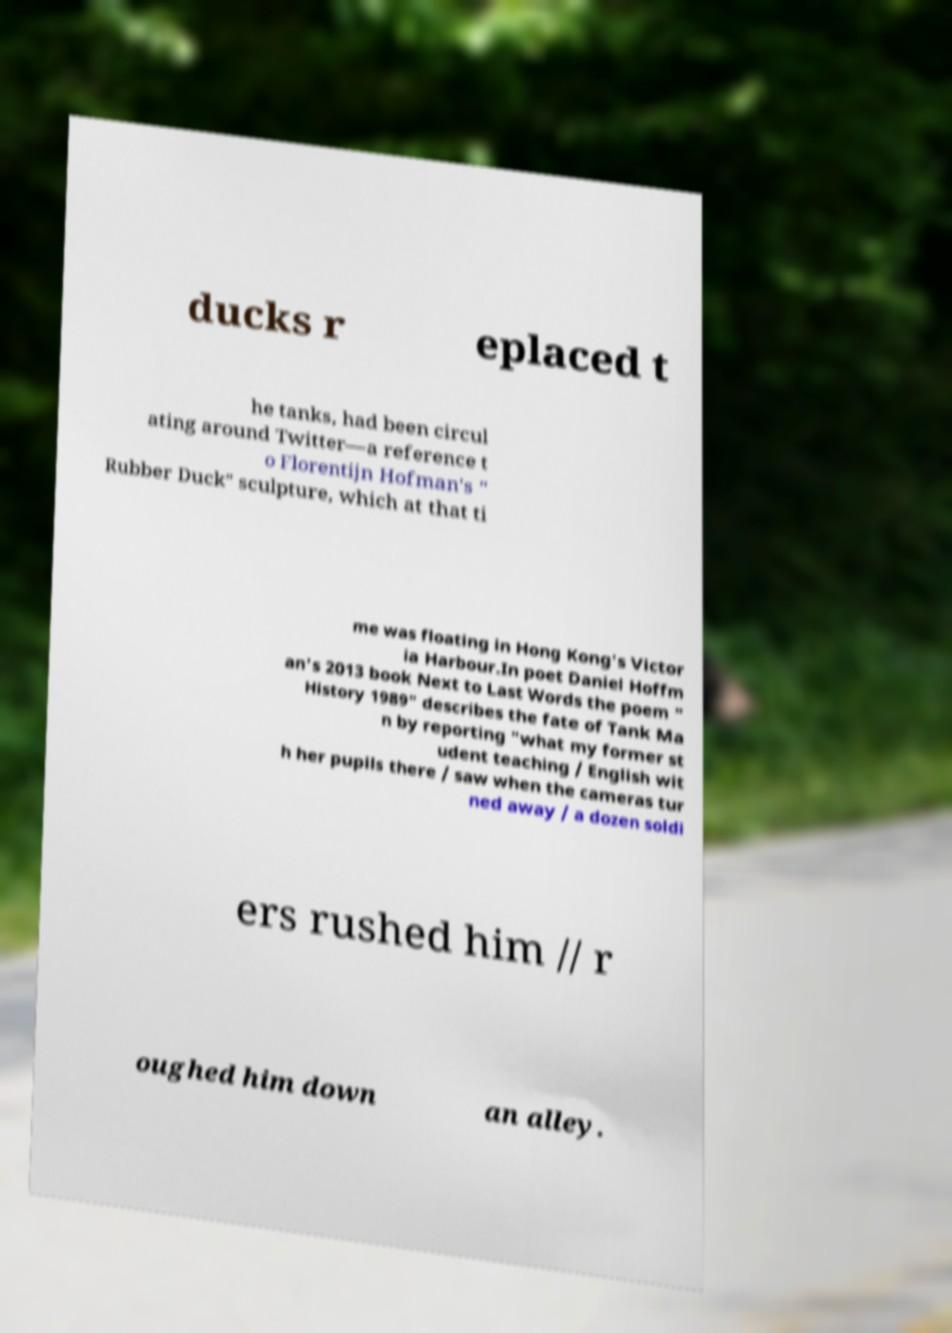Please identify and transcribe the text found in this image. ducks r eplaced t he tanks, had been circul ating around Twitter—a reference t o Florentijn Hofman's " Rubber Duck" sculpture, which at that ti me was floating in Hong Kong's Victor ia Harbour.In poet Daniel Hoffm an's 2013 book Next to Last Words the poem " History 1989" describes the fate of Tank Ma n by reporting "what my former st udent teaching / English wit h her pupils there / saw when the cameras tur ned away / a dozen soldi ers rushed him // r oughed him down an alley. 